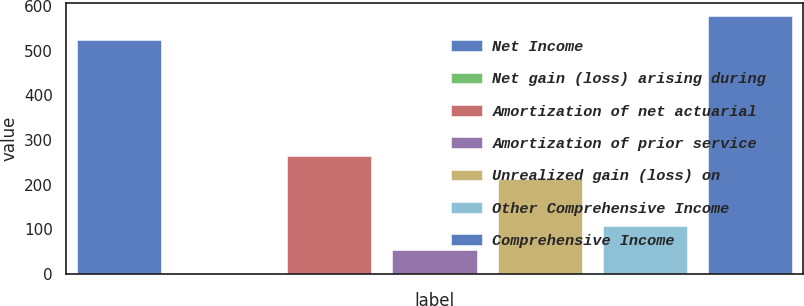<chart> <loc_0><loc_0><loc_500><loc_500><bar_chart><fcel>Net Income<fcel>Net gain (loss) arising during<fcel>Amortization of net actuarial<fcel>Amortization of prior service<fcel>Unrealized gain (loss) on<fcel>Other Comprehensive Income<fcel>Comprehensive Income<nl><fcel>525<fcel>1<fcel>264<fcel>53.6<fcel>211.4<fcel>106.2<fcel>577.6<nl></chart> 